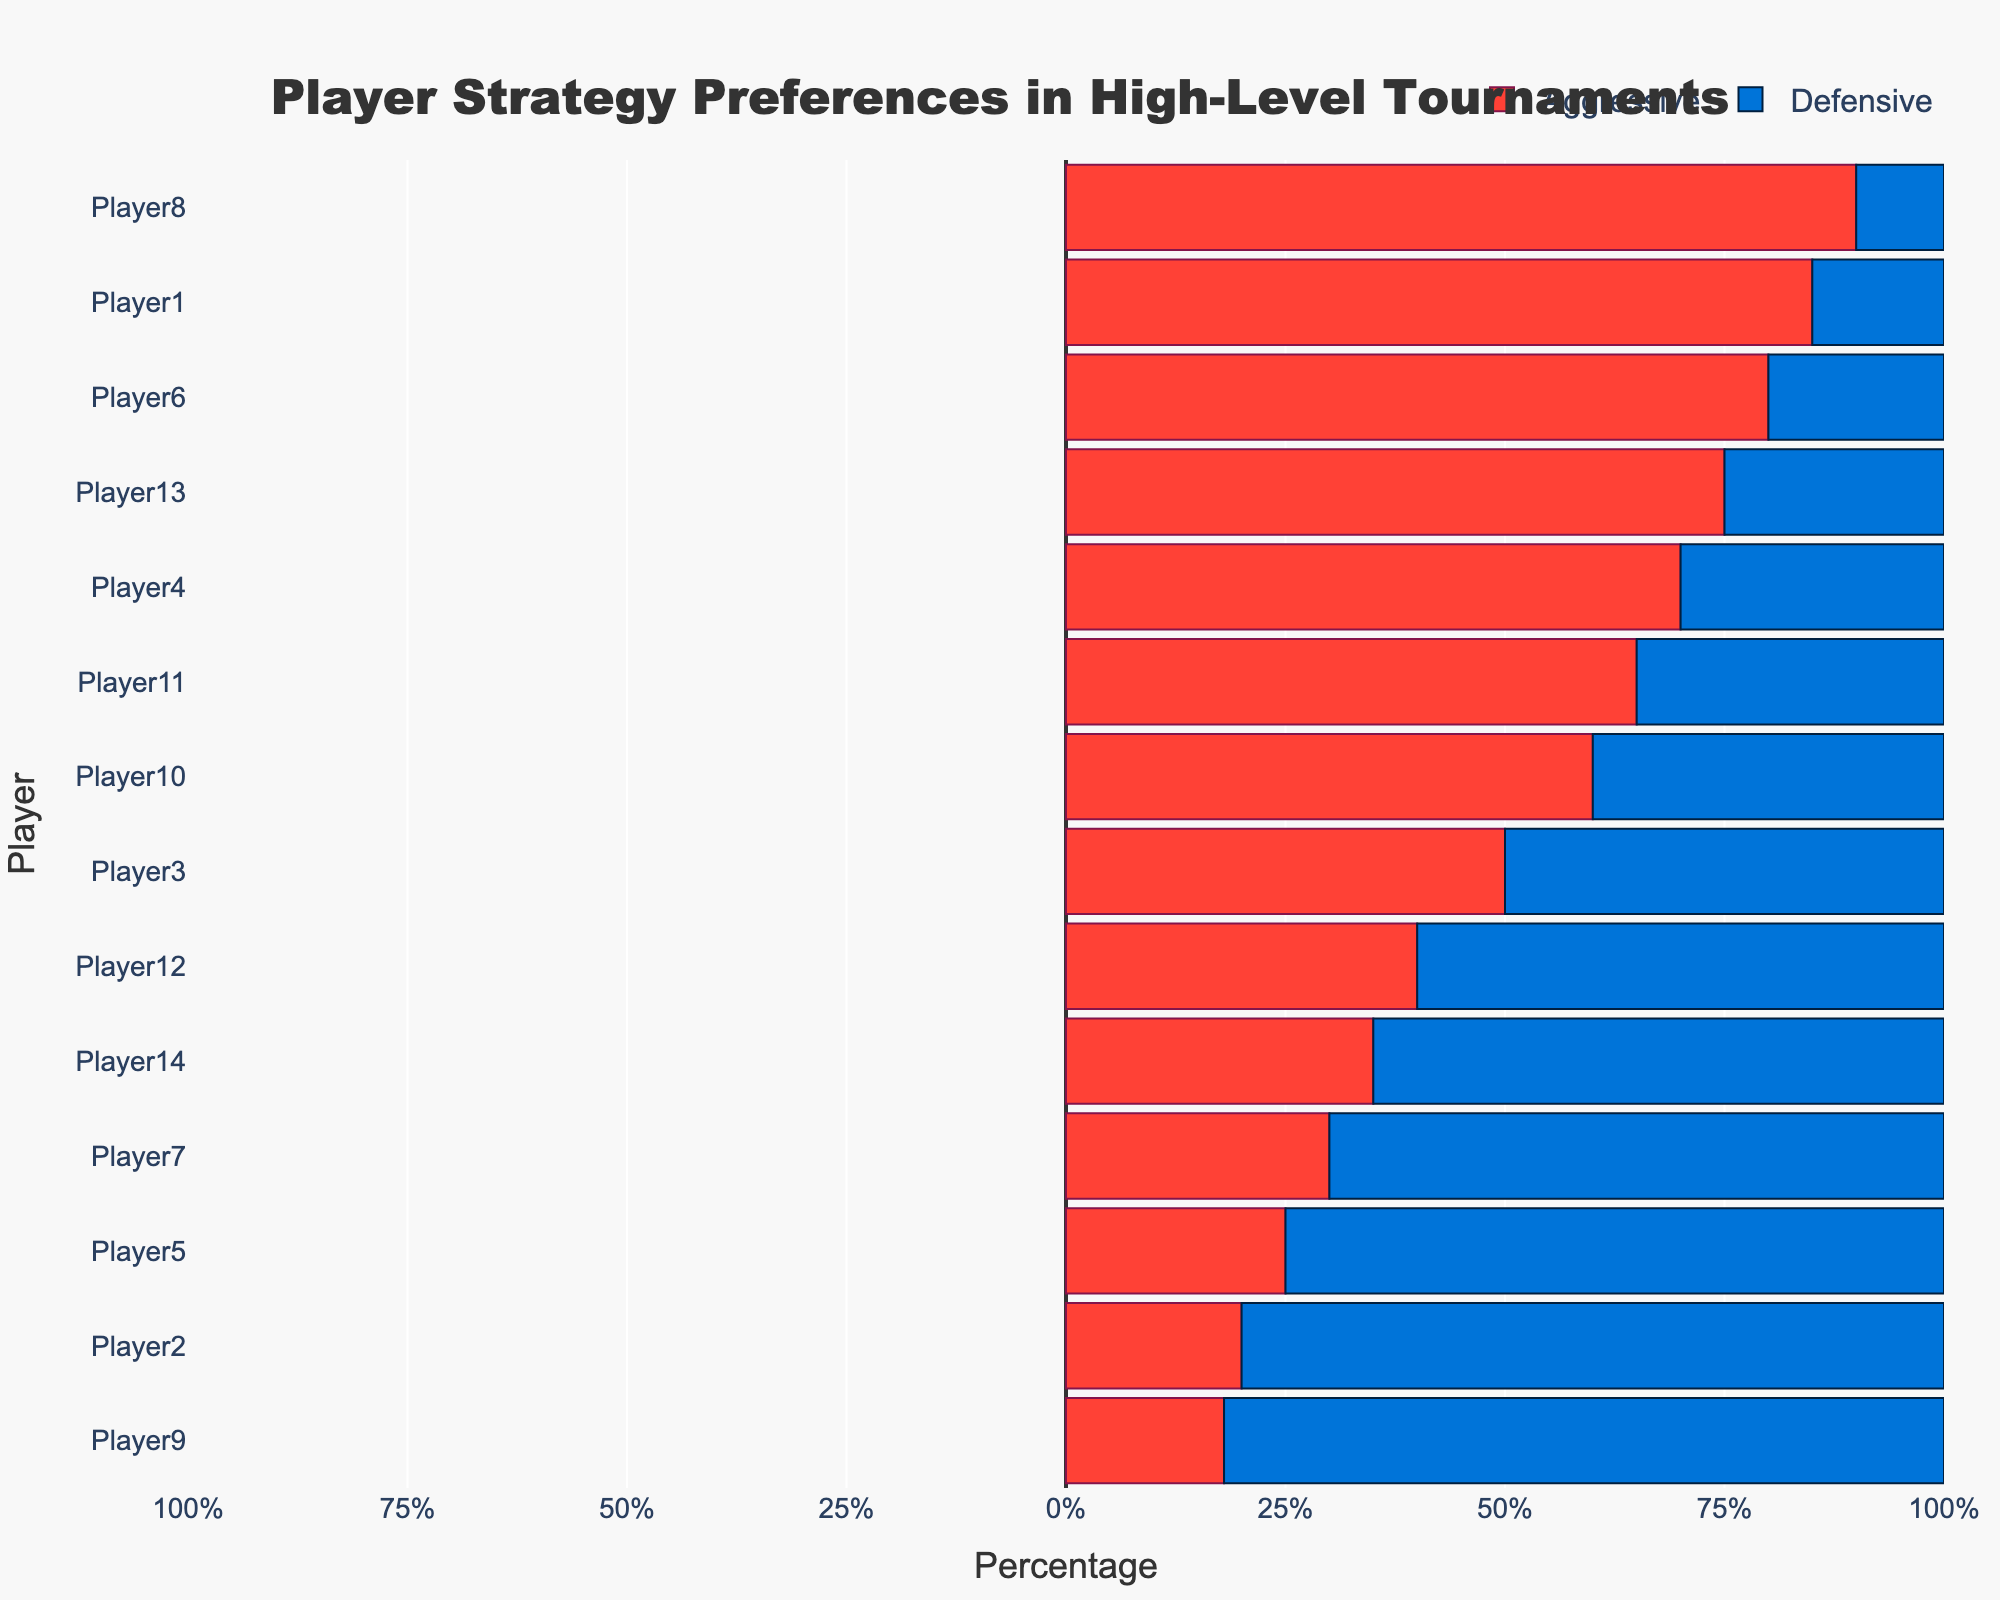What is the total percentage of aggressive tactics for Player1 and Player8 combined? To find the total percentage of aggressive tactics for Player1 and Player8 combined, add the aggressive percentages: Player1 (85%) + Player8 (90%) = 175%
Answer: 175% Which player has the lowest percentage of defensive tactics in the World Championships? To find the player with the lowest percentage of defensive tactics in the World Championships, look at the defensive percentages among players in this tournament. Player1 has 15%, Player3 has 50%, Player8 has 10%, Player13 has 25% and Player2 has 80%, and Player9 has 82%. Player8 has the lowest defensive percentage of 10%
Answer: Player8 Compare the defensive percentage of Player12 and Player14. Who has a higher defensive percentage? To compare the defensive percentages, look at the defensive percentages for Player12 (60%) and Player14 (65%). Player14's defensive percentage (65%) is higher.
Answer: Player14 Which tournament has the highest number of players with mixed strategies? To determine which tournament has the highest number of players with mixed strategies, count the players with a 50/50 aggressive/defensive split per tournament. World Championships: Player3 (Mixed), Regional Championships: Player10 (Mixed). The World Championships has a higher number of mixed strategy players (1).
Answer: World Championships What is the average aggressive percentage for players with aggressive strategies across all tournaments? To find the average aggressive percentage for players with aggressive strategies, sum their aggressive percentages and divide by the number of such players. Players: Player1 (85%), Player4 (70%), Player6 (80%), Player8 (90%), Player11 (65%), Player13 (75%). Average: (85% + 70% + 80% + 90% + 65% + 75%) / 6 = 77.5%
Answer: 77.5% Is there any player with an exact 50/50 aggressive/defensive split? If so, who? To find if there's any player with an exact 50/50 split, look for players where the aggressive percentage equals the defensive percentage. Player3 and Player10 have 50% aggressive and 50% defensive.
Answer: Player3, Player10 Which tournament features the most diverse range of strategies from aggressive to defensive? To determine the tournament with the most diverse range of strategies, we can consider the range of aggressive and defensive percentages. In the World Championships: aggressive percentages range from 18% to 90% and defensive percentages from 10% to 82%, showing the most diversity.
Answer: World Championships How many players predominantly use defensive tactics (more than 50% defensive) in the National Championships? To find how many players predominantly use defensive tactics in the National Championships, count those with a defensive percentage greater than 50%. Players: Player5 (75%) and Player12 (60%)
Answer: 2 Who has a balance closer to being perfectly mixed, Player3 or Player10? To determine who is closer to perfectly mixed, look for the smallest difference between aggressive and defensive percentages. Player3 has a difference of 0% (50% aggressive vs 50% defensive), and Player10 has a difference of 20% (60% aggressive vs. 40% defensive). Player3 is closer.
Answer: Player3 